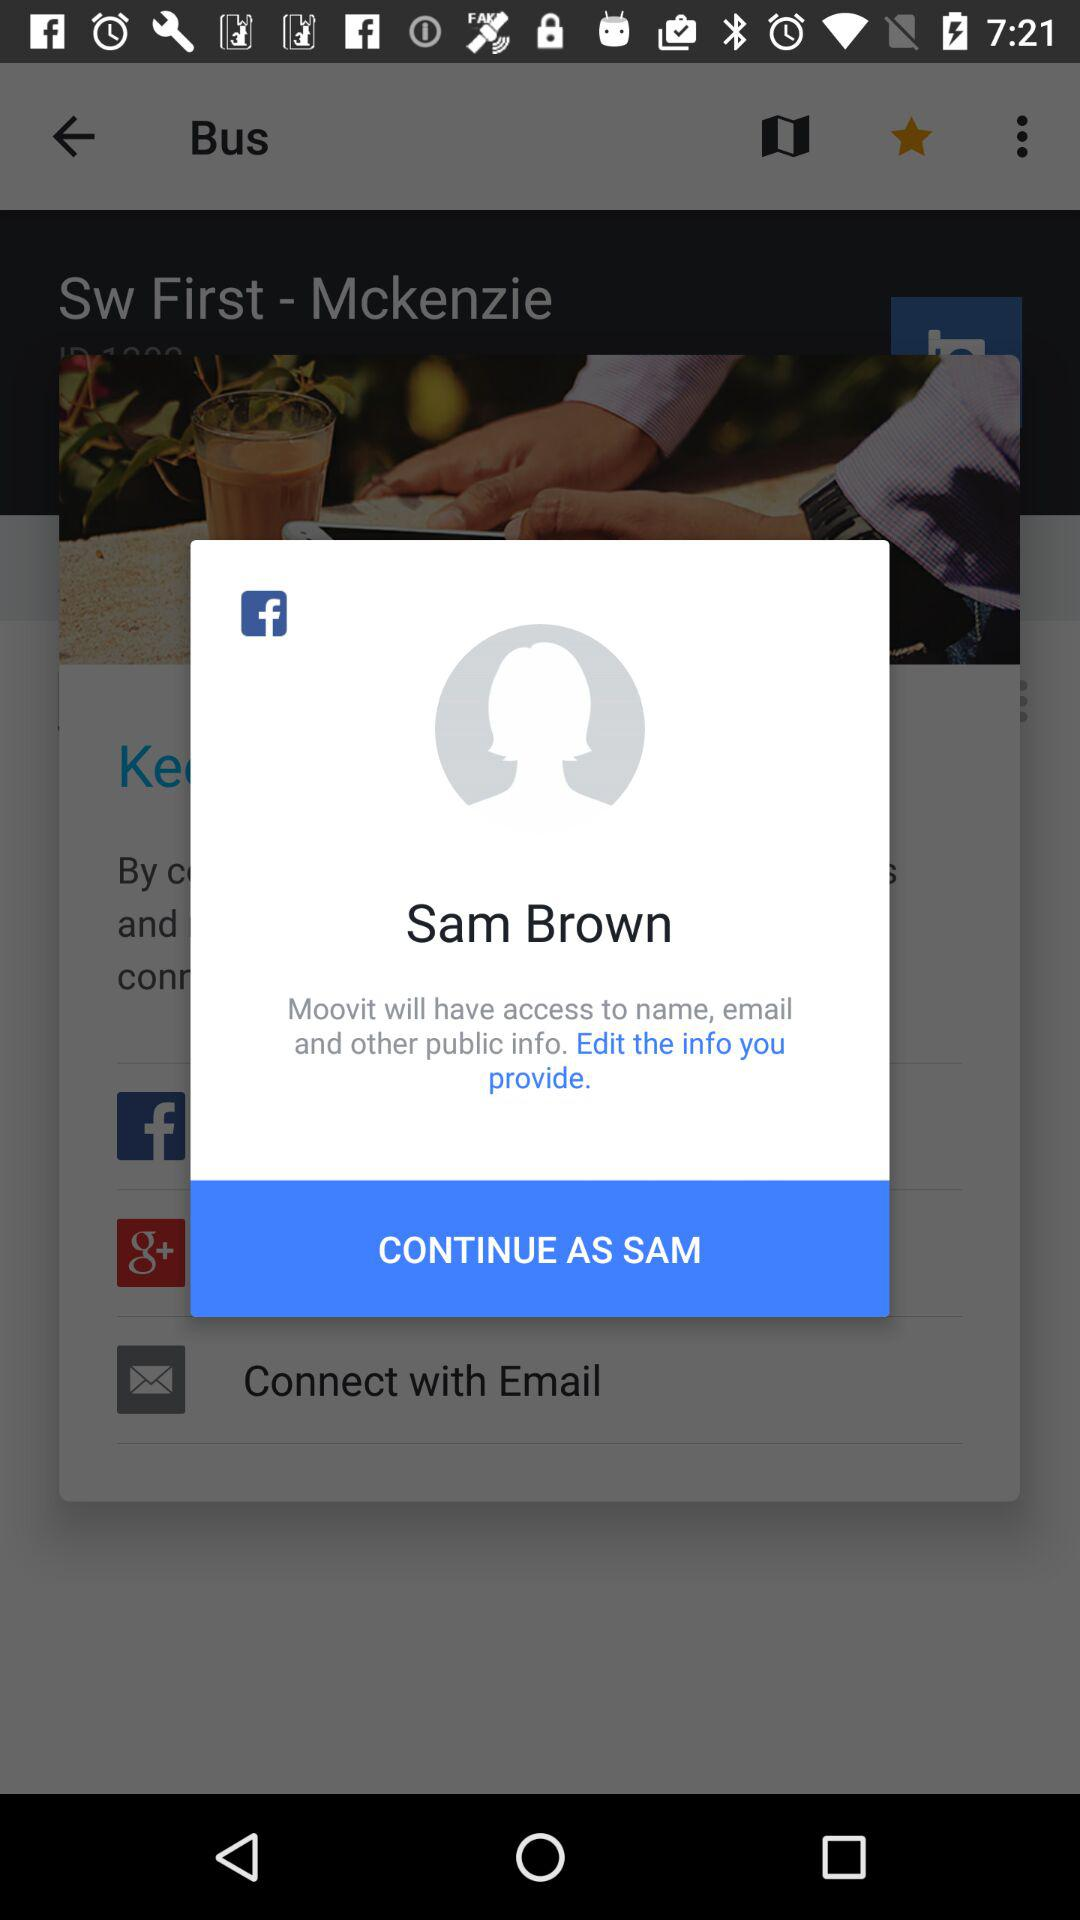What is the name of the user? The name of the user is Sam Brown. 